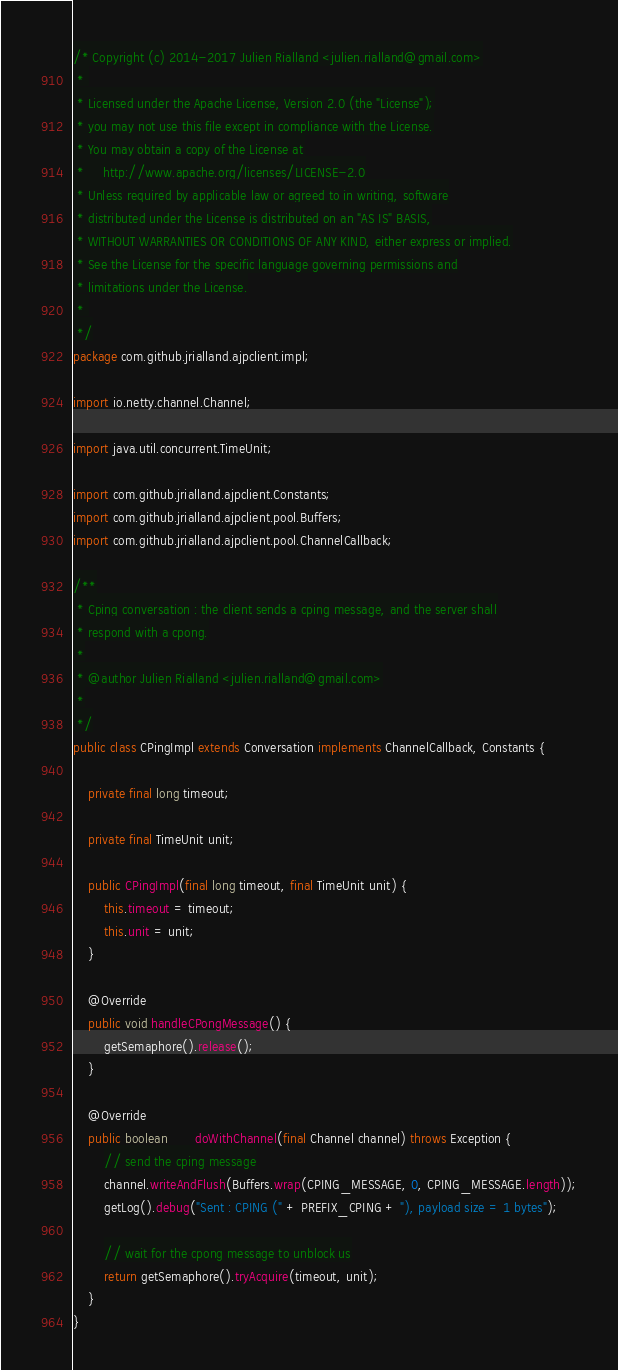<code> <loc_0><loc_0><loc_500><loc_500><_Java_>/* Copyright (c) 2014-2017 Julien Rialland <julien.rialland@gmail.com>
 * 
 * Licensed under the Apache License, Version 2.0 (the "License");
 * you may not use this file except in compliance with the License.
 * You may obtain a copy of the License at
 *     http://www.apache.org/licenses/LICENSE-2.0
 * Unless required by applicable law or agreed to in writing, software
 * distributed under the License is distributed on an "AS IS" BASIS,
 * WITHOUT WARRANTIES OR CONDITIONS OF ANY KIND, either express or implied.
 * See the License for the specific language governing permissions and
 * limitations under the License.
 * 
 */
package com.github.jrialland.ajpclient.impl;

import io.netty.channel.Channel;

import java.util.concurrent.TimeUnit;

import com.github.jrialland.ajpclient.Constants;
import com.github.jrialland.ajpclient.pool.Buffers;
import com.github.jrialland.ajpclient.pool.ChannelCallback;

/**
 * Cping conversation : the client sends a cping message, and the server shall
 * respond with a cpong.
 *
 * @author Julien Rialland <julien.rialland@gmail.com>
 *
 */
public class CPingImpl extends Conversation implements ChannelCallback, Constants {

	private final long timeout;

	private final TimeUnit unit;

	public CPingImpl(final long timeout, final TimeUnit unit) {
		this.timeout = timeout;
		this.unit = unit;
	}

	@Override
	public void handleCPongMessage() {
		getSemaphore().release();
	}

	@Override
	public boolean __doWithChannel(final Channel channel) throws Exception {
		// send the cping message
		channel.writeAndFlush(Buffers.wrap(CPING_MESSAGE, 0, CPING_MESSAGE.length));
		getLog().debug("Sent : CPING (" + PREFIX_CPING + "), payload size = 1 bytes");

		// wait for the cpong message to unblock us
		return getSemaphore().tryAcquire(timeout, unit);
	}
}
</code> 